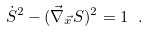Convert formula to latex. <formula><loc_0><loc_0><loc_500><loc_500>\dot { S } ^ { 2 } - ( { \vec { \nabla } _ { \vec { x } } } S ) ^ { 2 } = 1 \ .</formula> 